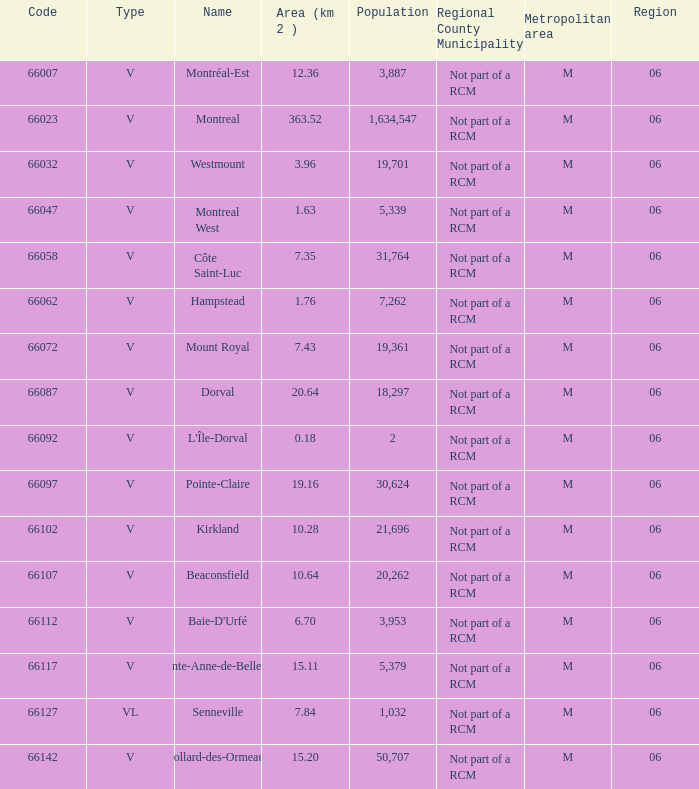Help me parse the entirety of this table. {'header': ['Code', 'Type', 'Name', 'Area (km 2 )', 'Population', 'Regional County Municipality', 'Metropolitan area', 'Region'], 'rows': [['66007', 'V', 'Montréal-Est', '12.36', '3,887', 'Not part of a RCM', 'M', '06'], ['66023', 'V', 'Montreal', '363.52', '1,634,547', 'Not part of a RCM', 'M', '06'], ['66032', 'V', 'Westmount', '3.96', '19,701', 'Not part of a RCM', 'M', '06'], ['66047', 'V', 'Montreal West', '1.63', '5,339', 'Not part of a RCM', 'M', '06'], ['66058', 'V', 'Côte Saint-Luc', '7.35', '31,764', 'Not part of a RCM', 'M', '06'], ['66062', 'V', 'Hampstead', '1.76', '7,262', 'Not part of a RCM', 'M', '06'], ['66072', 'V', 'Mount Royal', '7.43', '19,361', 'Not part of a RCM', 'M', '06'], ['66087', 'V', 'Dorval', '20.64', '18,297', 'Not part of a RCM', 'M', '06'], ['66092', 'V', "L'Île-Dorval", '0.18', '2', 'Not part of a RCM', 'M', '06'], ['66097', 'V', 'Pointe-Claire', '19.16', '30,624', 'Not part of a RCM', 'M', '06'], ['66102', 'V', 'Kirkland', '10.28', '21,696', 'Not part of a RCM', 'M', '06'], ['66107', 'V', 'Beaconsfield', '10.64', '20,262', 'Not part of a RCM', 'M', '06'], ['66112', 'V', "Baie-D'Urfé", '6.70', '3,953', 'Not part of a RCM', 'M', '06'], ['66117', 'V', 'Sainte-Anne-de-Bellevue', '15.11', '5,379', 'Not part of a RCM', 'M', '06'], ['66127', 'VL', 'Senneville', '7.84', '1,032', 'Not part of a RCM', 'M', '06'], ['66142', 'V', 'Dollard-des-Ormeaux', '15.20', '50,707', 'Not part of a RCM', 'M', '06']]} What is the most extensive area with a code of 66097, and a region bigger than 6? None. 